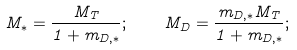<formula> <loc_0><loc_0><loc_500><loc_500>M _ { \ast } = \frac { M _ { T } } { 1 + m _ { D , \ast } } ; \quad M _ { D } = \frac { m _ { D , \ast } M _ { T } } { 1 + m _ { D , \ast } } ;</formula> 